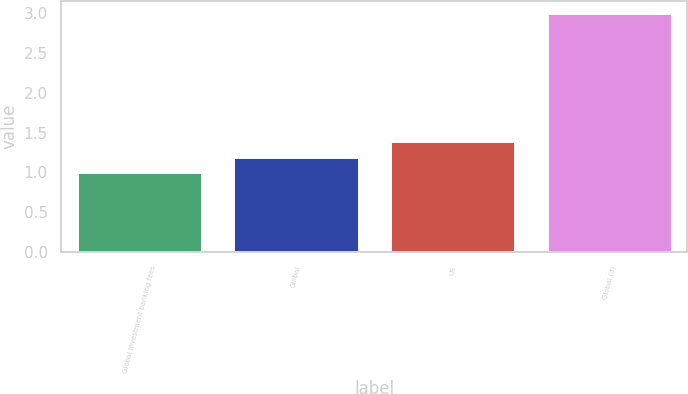<chart> <loc_0><loc_0><loc_500><loc_500><bar_chart><fcel>Global investment banking fees<fcel>Global<fcel>US<fcel>Global (d)<nl><fcel>1<fcel>1.2<fcel>1.4<fcel>3<nl></chart> 